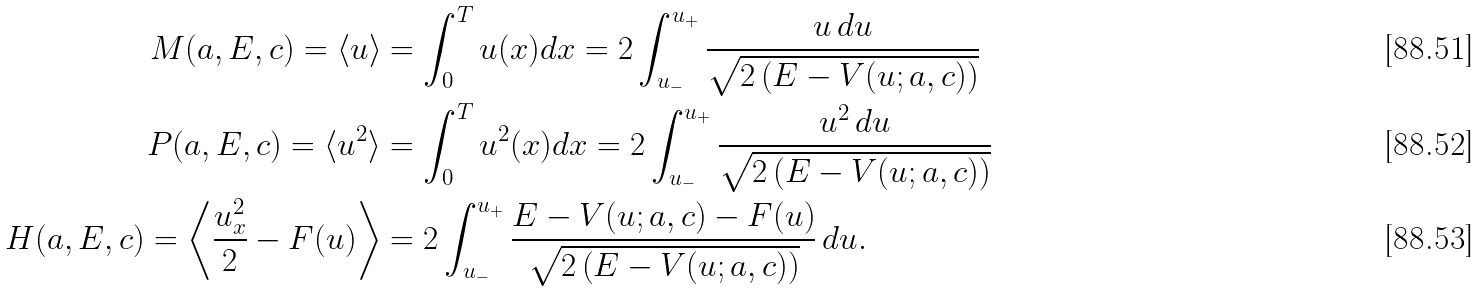<formula> <loc_0><loc_0><loc_500><loc_500>M ( a , E , c ) = \langle u \rangle & = \int _ { 0 } ^ { T } u ( x ) d x = 2 \int _ { u _ { - } } ^ { u _ { + } } \frac { u \, d u } { \sqrt { 2 \left ( E - V ( u ; a , c ) \right ) } } \\ P ( a , E , c ) = \langle u ^ { 2 } \rangle & = \int _ { 0 } ^ { T } u ^ { 2 } ( x ) d x = 2 \int _ { u _ { - } } ^ { u _ { + } } \frac { u ^ { 2 } \, d u } { \sqrt { 2 \left ( E - V ( u ; a , c ) \right ) } } \\ H ( a , E , c ) = \left \langle \frac { u _ { x } ^ { 2 } } { 2 } - F ( u ) \right \rangle & = 2 \int _ { u _ { - } } ^ { u _ { + } } \frac { E - V ( u ; a , c ) - F ( u ) } { \sqrt { 2 \left ( E - V ( u ; a , c ) \right ) } } \, d u .</formula> 